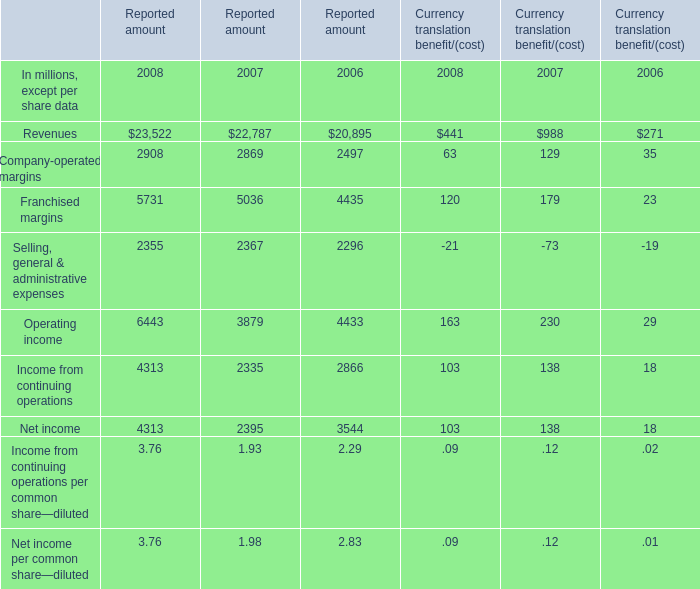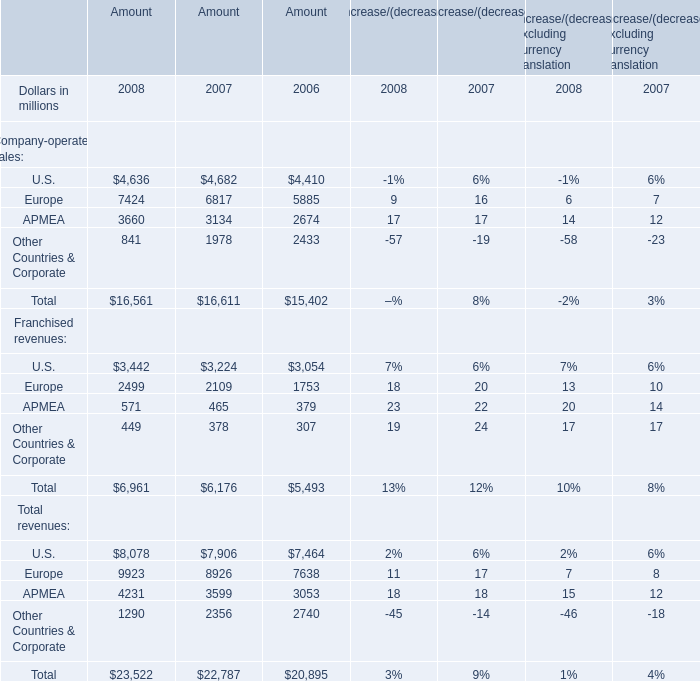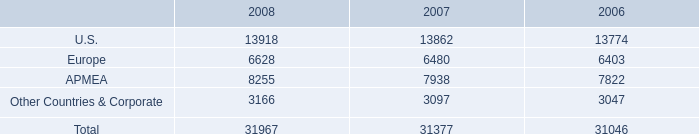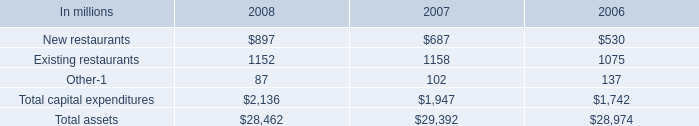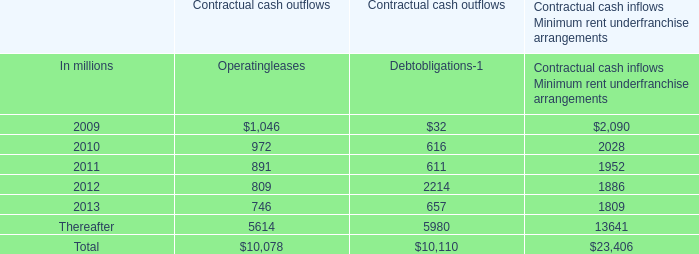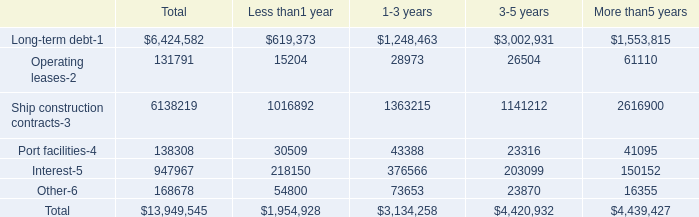What's the average of Selling, general & administrative expenses and Franchised margins in 2008 for Reported amount? (in million) 
Computations: ((5731 + 2355) / 2)
Answer: 4043.0. 